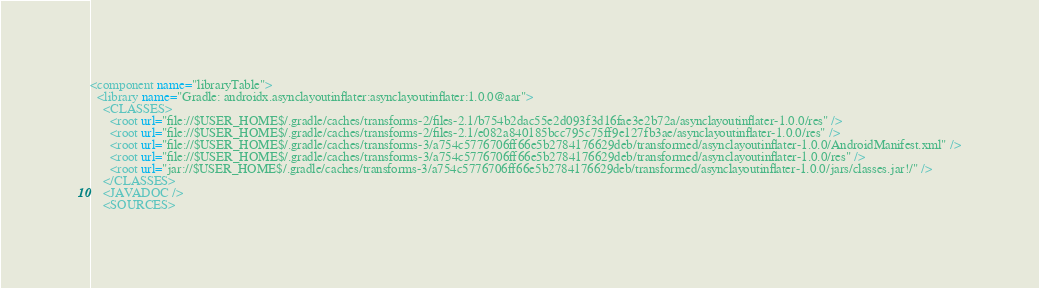<code> <loc_0><loc_0><loc_500><loc_500><_XML_><component name="libraryTable">
  <library name="Gradle: androidx.asynclayoutinflater:asynclayoutinflater:1.0.0@aar">
    <CLASSES>
      <root url="file://$USER_HOME$/.gradle/caches/transforms-2/files-2.1/b754b2dac55e2d093f3d16fae3e2b72a/asynclayoutinflater-1.0.0/res" />
      <root url="file://$USER_HOME$/.gradle/caches/transforms-2/files-2.1/e082a840185bcc795c75ff9e127fb3ae/asynclayoutinflater-1.0.0/res" />
      <root url="file://$USER_HOME$/.gradle/caches/transforms-3/a754c5776706ff66e5b2784176629deb/transformed/asynclayoutinflater-1.0.0/AndroidManifest.xml" />
      <root url="file://$USER_HOME$/.gradle/caches/transforms-3/a754c5776706ff66e5b2784176629deb/transformed/asynclayoutinflater-1.0.0/res" />
      <root url="jar://$USER_HOME$/.gradle/caches/transforms-3/a754c5776706ff66e5b2784176629deb/transformed/asynclayoutinflater-1.0.0/jars/classes.jar!/" />
    </CLASSES>
    <JAVADOC />
    <SOURCES></code> 